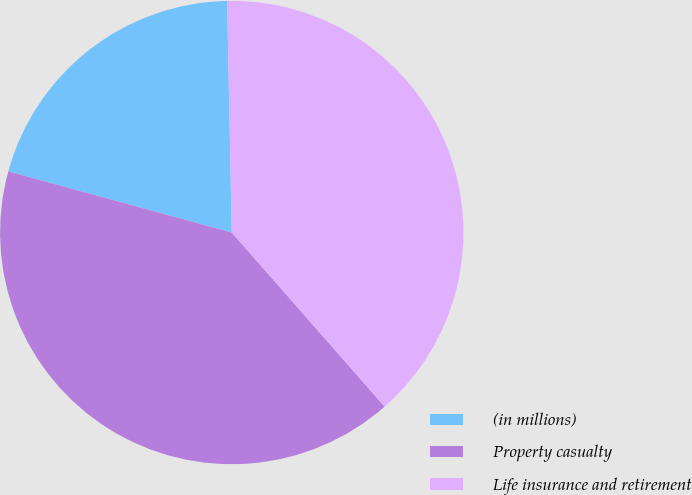Convert chart to OTSL. <chart><loc_0><loc_0><loc_500><loc_500><pie_chart><fcel>(in millions)<fcel>Property casualty<fcel>Life insurance and retirement<nl><fcel>20.43%<fcel>40.72%<fcel>38.85%<nl></chart> 